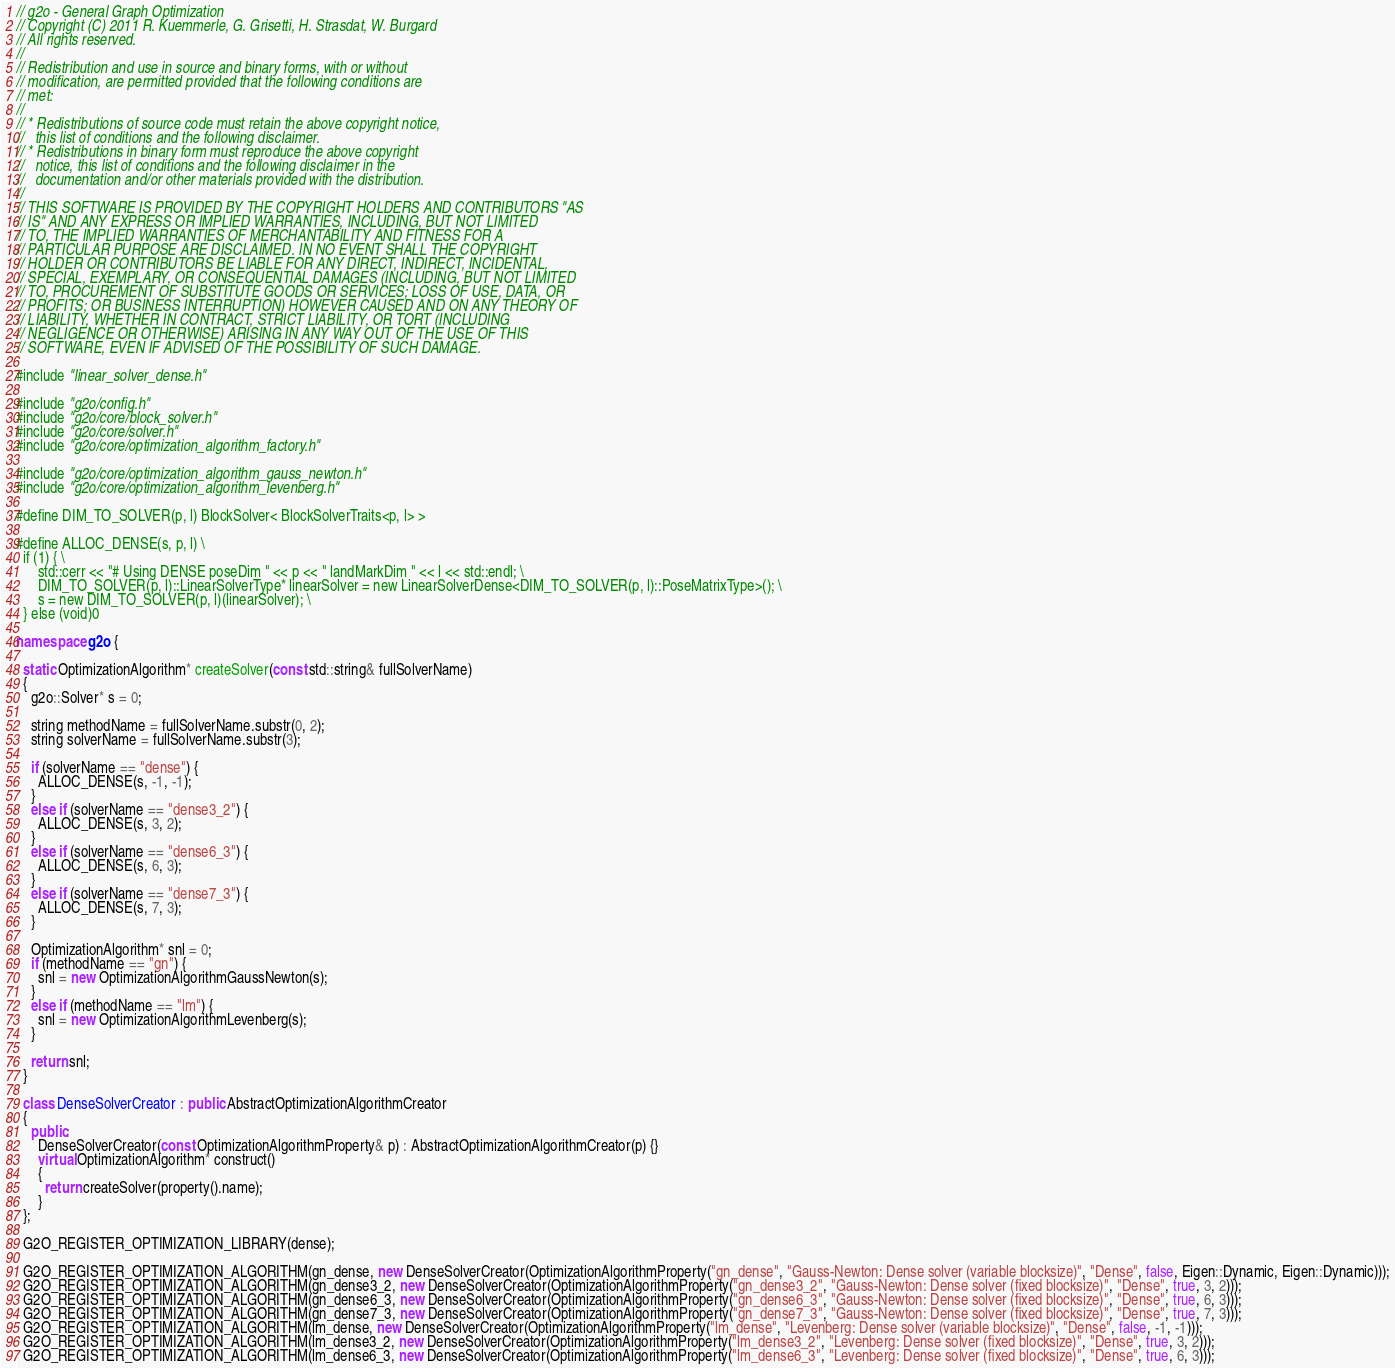<code> <loc_0><loc_0><loc_500><loc_500><_C++_>// g2o - General Graph Optimization
// Copyright (C) 2011 R. Kuemmerle, G. Grisetti, H. Strasdat, W. Burgard
// All rights reserved.
//
// Redistribution and use in source and binary forms, with or without
// modification, are permitted provided that the following conditions are
// met:
//
// * Redistributions of source code must retain the above copyright notice,
//   this list of conditions and the following disclaimer.
// * Redistributions in binary form must reproduce the above copyright
//   notice, this list of conditions and the following disclaimer in the
//   documentation and/or other materials provided with the distribution.
//
// THIS SOFTWARE IS PROVIDED BY THE COPYRIGHT HOLDERS AND CONTRIBUTORS "AS
// IS" AND ANY EXPRESS OR IMPLIED WARRANTIES, INCLUDING, BUT NOT LIMITED
// TO, THE IMPLIED WARRANTIES OF MERCHANTABILITY AND FITNESS FOR A
// PARTICULAR PURPOSE ARE DISCLAIMED. IN NO EVENT SHALL THE COPYRIGHT
// HOLDER OR CONTRIBUTORS BE LIABLE FOR ANY DIRECT, INDIRECT, INCIDENTAL,
// SPECIAL, EXEMPLARY, OR CONSEQUENTIAL DAMAGES (INCLUDING, BUT NOT LIMITED
// TO, PROCUREMENT OF SUBSTITUTE GOODS OR SERVICES; LOSS OF USE, DATA, OR
// PROFITS; OR BUSINESS INTERRUPTION) HOWEVER CAUSED AND ON ANY THEORY OF
// LIABILITY, WHETHER IN CONTRACT, STRICT LIABILITY, OR TORT (INCLUDING
// NEGLIGENCE OR OTHERWISE) ARISING IN ANY WAY OUT OF THE USE OF THIS
// SOFTWARE, EVEN IF ADVISED OF THE POSSIBILITY OF SUCH DAMAGE.

#include "linear_solver_dense.h"

#include "g2o/config.h"
#include "g2o/core/block_solver.h"
#include "g2o/core/solver.h"
#include "g2o/core/optimization_algorithm_factory.h"

#include "g2o/core/optimization_algorithm_gauss_newton.h"
#include "g2o/core/optimization_algorithm_levenberg.h"

#define DIM_TO_SOLVER(p, l) BlockSolver< BlockSolverTraits<p, l> >

#define ALLOC_DENSE(s, p, l) \
  if (1) { \
      std::cerr << "# Using DENSE poseDim " << p << " landMarkDim " << l << std::endl; \
      DIM_TO_SOLVER(p, l)::LinearSolverType* linearSolver = new LinearSolverDense<DIM_TO_SOLVER(p, l)::PoseMatrixType>(); \
      s = new DIM_TO_SOLVER(p, l)(linearSolver); \
  } else (void)0

namespace g2o {

  static OptimizationAlgorithm* createSolver(const std::string& fullSolverName)
  {
    g2o::Solver* s = 0;

    string methodName = fullSolverName.substr(0, 2);
    string solverName = fullSolverName.substr(3);

    if (solverName == "dense") {
      ALLOC_DENSE(s, -1, -1);
    }
    else if (solverName == "dense3_2") {
      ALLOC_DENSE(s, 3, 2);
    }
    else if (solverName == "dense6_3") {
      ALLOC_DENSE(s, 6, 3);
    }
    else if (solverName == "dense7_3") {
      ALLOC_DENSE(s, 7, 3);
    }

    OptimizationAlgorithm* snl = 0;
    if (methodName == "gn") {
      snl = new OptimizationAlgorithmGaussNewton(s);
    }
    else if (methodName == "lm") {
      snl = new OptimizationAlgorithmLevenberg(s);
    }

    return snl;
  }

  class DenseSolverCreator : public AbstractOptimizationAlgorithmCreator
  {
    public:
      DenseSolverCreator(const OptimizationAlgorithmProperty& p) : AbstractOptimizationAlgorithmCreator(p) {}
      virtual OptimizationAlgorithm* construct()
      {
        return createSolver(property().name);
      }
  };

  G2O_REGISTER_OPTIMIZATION_LIBRARY(dense);

  G2O_REGISTER_OPTIMIZATION_ALGORITHM(gn_dense, new DenseSolverCreator(OptimizationAlgorithmProperty("gn_dense", "Gauss-Newton: Dense solver (variable blocksize)", "Dense", false, Eigen::Dynamic, Eigen::Dynamic)));
  G2O_REGISTER_OPTIMIZATION_ALGORITHM(gn_dense3_2, new DenseSolverCreator(OptimizationAlgorithmProperty("gn_dense3_2", "Gauss-Newton: Dense solver (fixed blocksize)", "Dense", true, 3, 2)));
  G2O_REGISTER_OPTIMIZATION_ALGORITHM(gn_dense6_3, new DenseSolverCreator(OptimizationAlgorithmProperty("gn_dense6_3", "Gauss-Newton: Dense solver (fixed blocksize)", "Dense", true, 6, 3)));
  G2O_REGISTER_OPTIMIZATION_ALGORITHM(gn_dense7_3, new DenseSolverCreator(OptimizationAlgorithmProperty("gn_dense7_3", "Gauss-Newton: Dense solver (fixed blocksize)", "Dense", true, 7, 3)));
  G2O_REGISTER_OPTIMIZATION_ALGORITHM(lm_dense, new DenseSolverCreator(OptimizationAlgorithmProperty("lm_dense", "Levenberg: Dense solver (variable blocksize)", "Dense", false, -1, -1)));
  G2O_REGISTER_OPTIMIZATION_ALGORITHM(lm_dense3_2, new DenseSolverCreator(OptimizationAlgorithmProperty("lm_dense3_2", "Levenberg: Dense solver (fixed blocksize)", "Dense", true, 3, 2)));
  G2O_REGISTER_OPTIMIZATION_ALGORITHM(lm_dense6_3, new DenseSolverCreator(OptimizationAlgorithmProperty("lm_dense6_3", "Levenberg: Dense solver (fixed blocksize)", "Dense", true, 6, 3)));</code> 